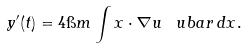Convert formula to latex. <formula><loc_0><loc_0><loc_500><loc_500>y ^ { \prime } ( t ) = 4 \i m \int x \cdot \nabla u \, \ u b a r \, d x .</formula> 